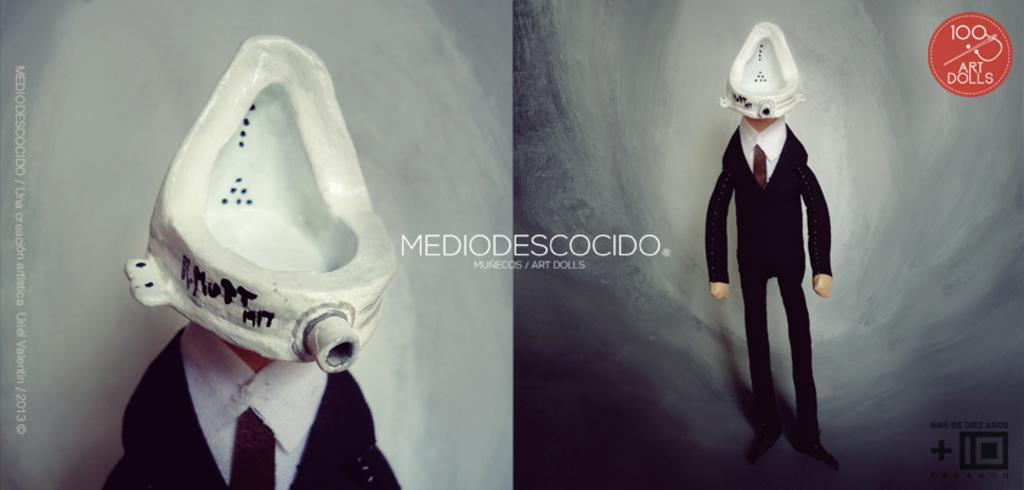What type of poster is in the image? There is a parallax poster in the image. What is depicted on the parallax poster? The poster features a person wearing a black suit. What is the position of the urinal basin in relation to the person in the poster? The urinal basin is positioned above the person's head in the poster. How much wealth does the person in the poster possess? The image does not provide any information about the person's wealth, as it only shows a parallax poster with a person wearing a black suit and a urinal basin above their head. 